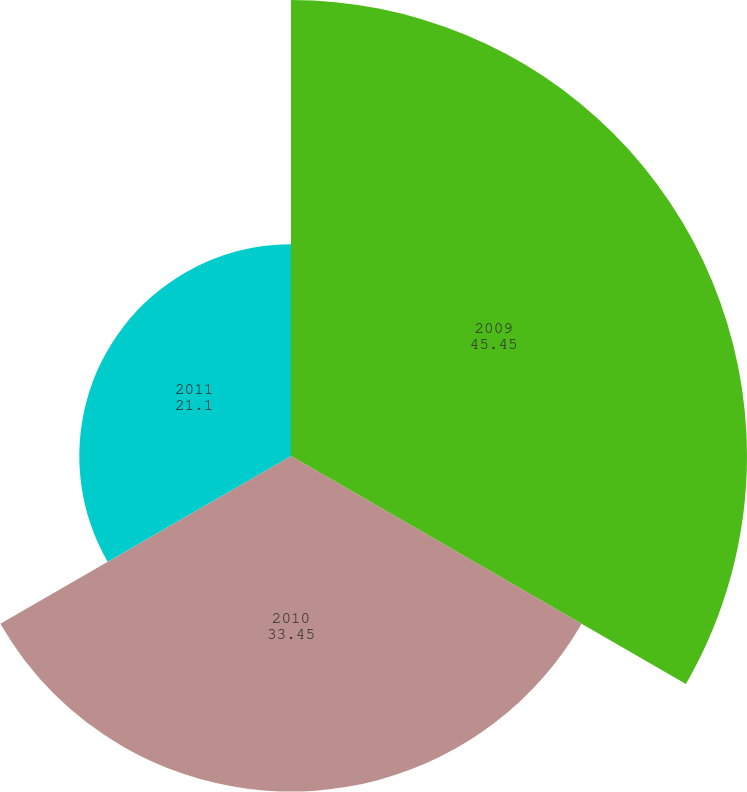<chart> <loc_0><loc_0><loc_500><loc_500><pie_chart><fcel>2009<fcel>2010<fcel>2011<nl><fcel>45.45%<fcel>33.45%<fcel>21.1%<nl></chart> 